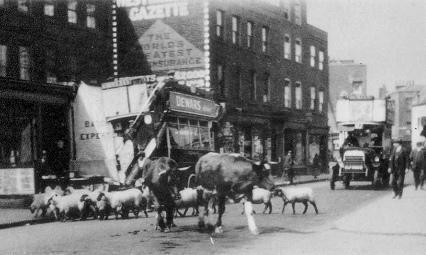What is in front of the vehicle?
Answer the question by selecting the correct answer among the 4 following choices and explain your choice with a short sentence. The answer should be formatted with the following format: `Answer: choice
Rationale: rationale.`
Options: Animals, traffic cones, eggs, balloons. Answer: animals.
Rationale: The animals are in front. 